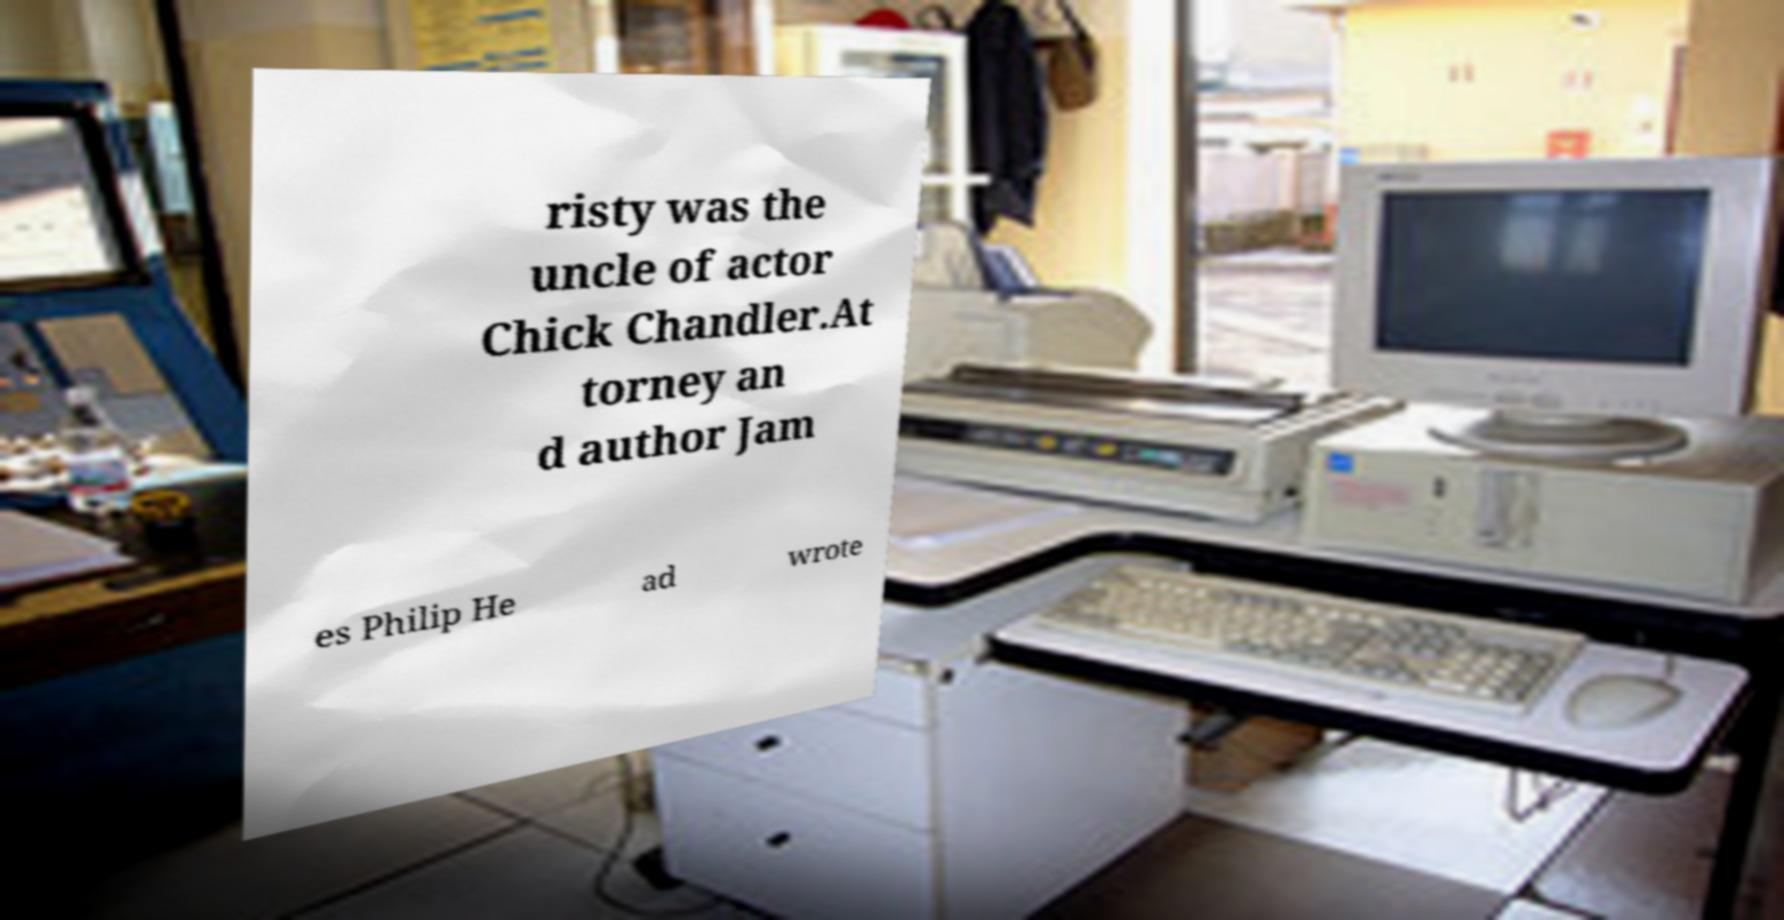Could you extract and type out the text from this image? risty was the uncle of actor Chick Chandler.At torney an d author Jam es Philip He ad wrote 